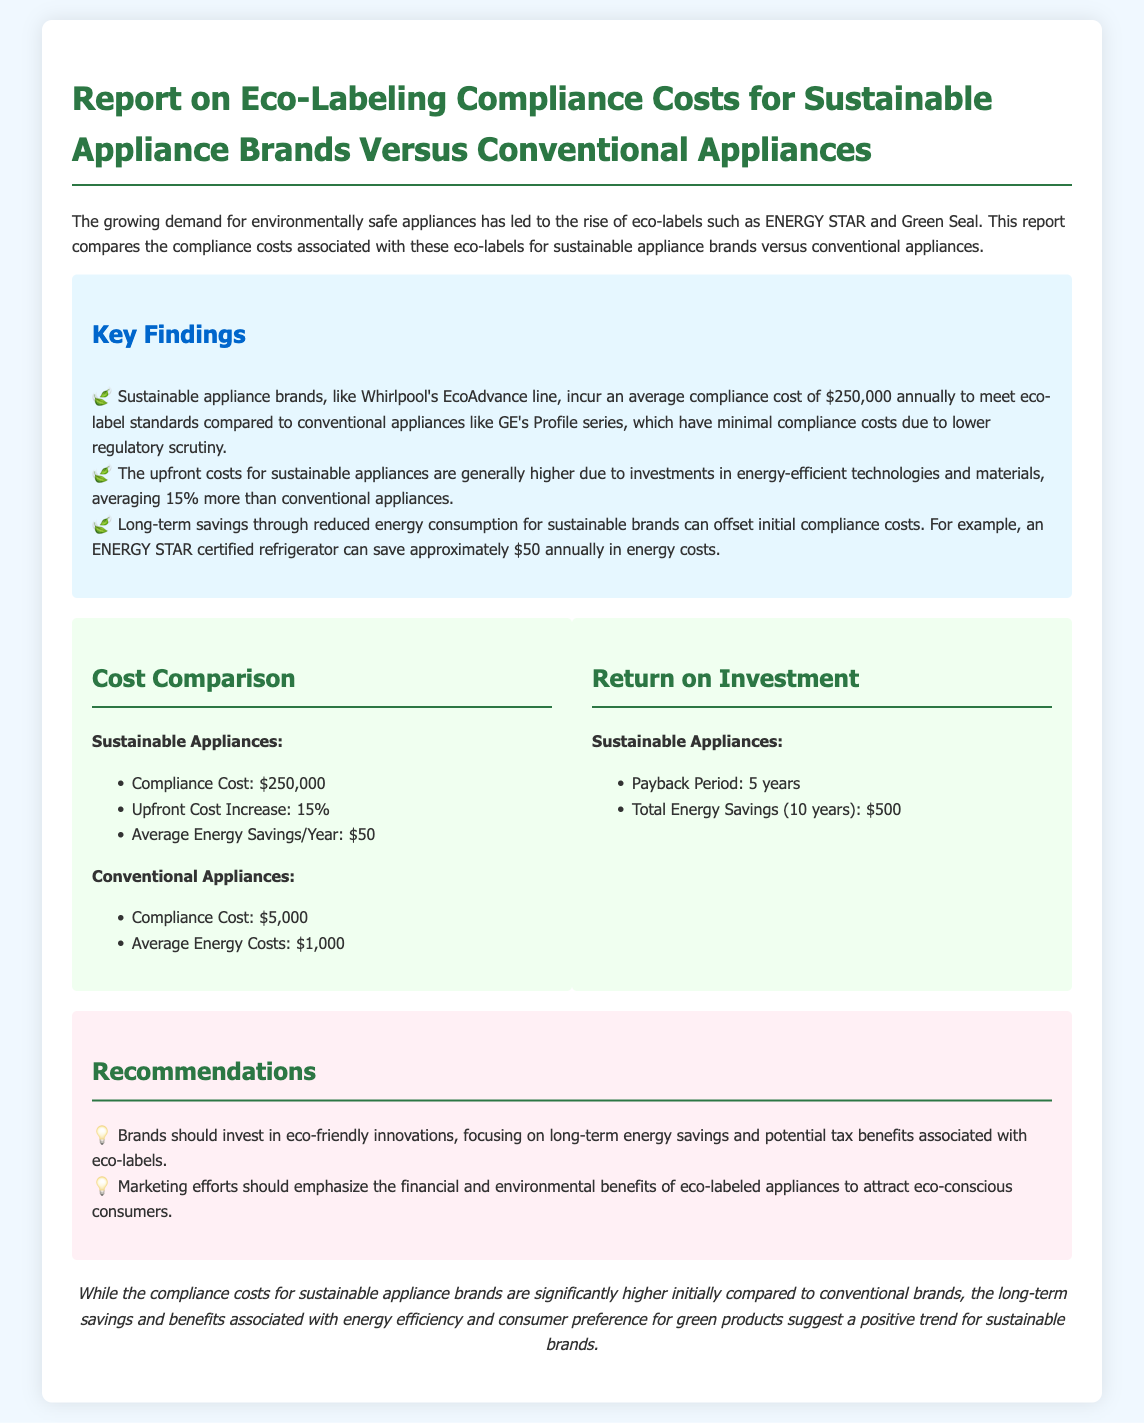What is the average compliance cost for sustainable appliance brands? The document states that sustainable appliance brands incur an average compliance cost of $250,000 annually.
Answer: $250,000 What is the compliance cost for conventional appliances? According to the document, the compliance cost for conventional appliances is $5,000.
Answer: $5,000 How much more are upfront costs for sustainable appliances compared to conventional ones? The report indicates that the upfront costs for sustainable appliances are generally 15% more than conventional appliances.
Answer: 15% What is the average annual energy savings for an ENERGY STAR certified refrigerator? The document mentions that an ENERGY STAR certified refrigerator can save approximately $50 annually in energy costs.
Answer: $50 What is the payback period for sustainable appliances? The report highlights that the payback period for sustainable appliances is 5 years.
Answer: 5 years What is the total energy savings over 10 years for sustainable appliances? According to the financial analysis, the total energy savings over 10 years for sustainable appliances is $500.
Answer: $500 What marketing emphasis should brands focus on to attract eco-conscious consumers? The recommendations suggest that marketing efforts should emphasize the financial and environmental benefits of eco-labeled appliances.
Answer: Financial and environmental benefits What is the primary purpose of eco-labels mentioned in the document? The document states that the growing demand for environmentally safe appliances has led to the rise of eco-labels.
Answer: Environmentally safe appliances What type of innovations should brands invest in according to the recommendations? Brands are suggested to invest in eco-friendly innovations as per the recommendations.
Answer: Eco-friendly innovations 